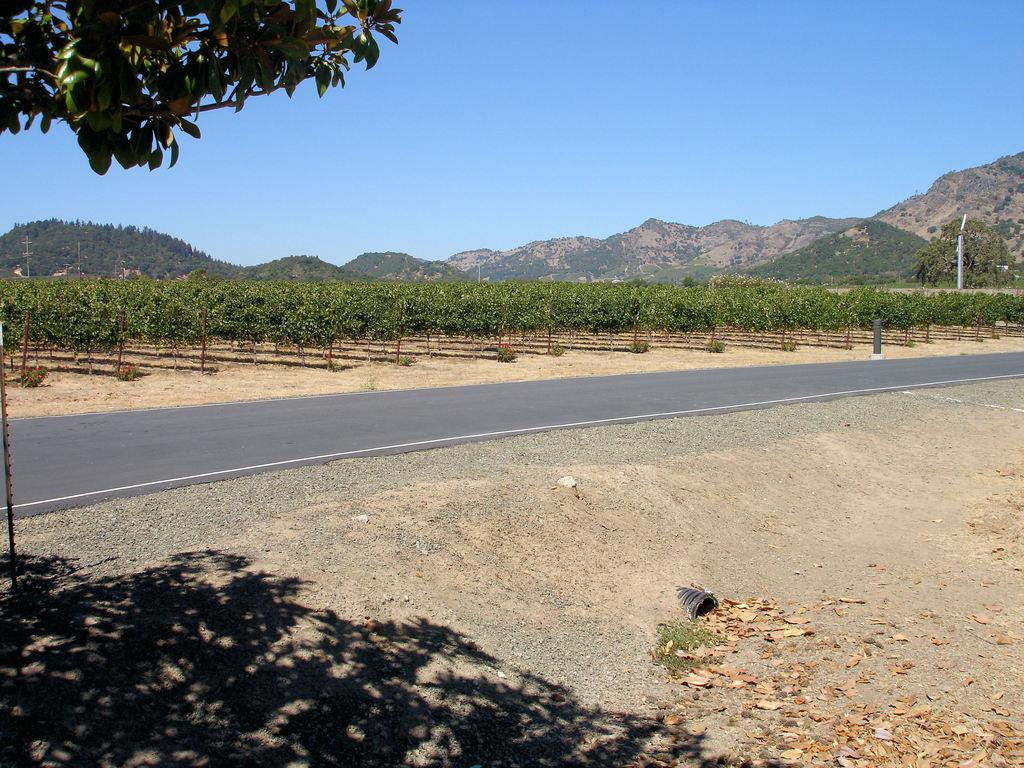What is the main feature of the image? There is a road in the image. What can be seen on the ground in the image? The ground is visible in the image. What type of structure is present in the image? There is a pipe in the image. What type of vegetation is present in the image? Plants and trees are visible in the image. What type of natural landform is visible in the image? Mountains are in the image. What type of man-made structures are present in the image? Poles are in the image. What is the condition of the sky in the image? The sky is clear at the top of the image. What type of tree is visible at the top of the image? Tree stems with leaves are visible at the top of the image. What type of underwear is hanging on the tree in the image? There is no underwear present in the image; it only features a road, ground, pipe, plants, trees, mountains, poles, and the sky. 